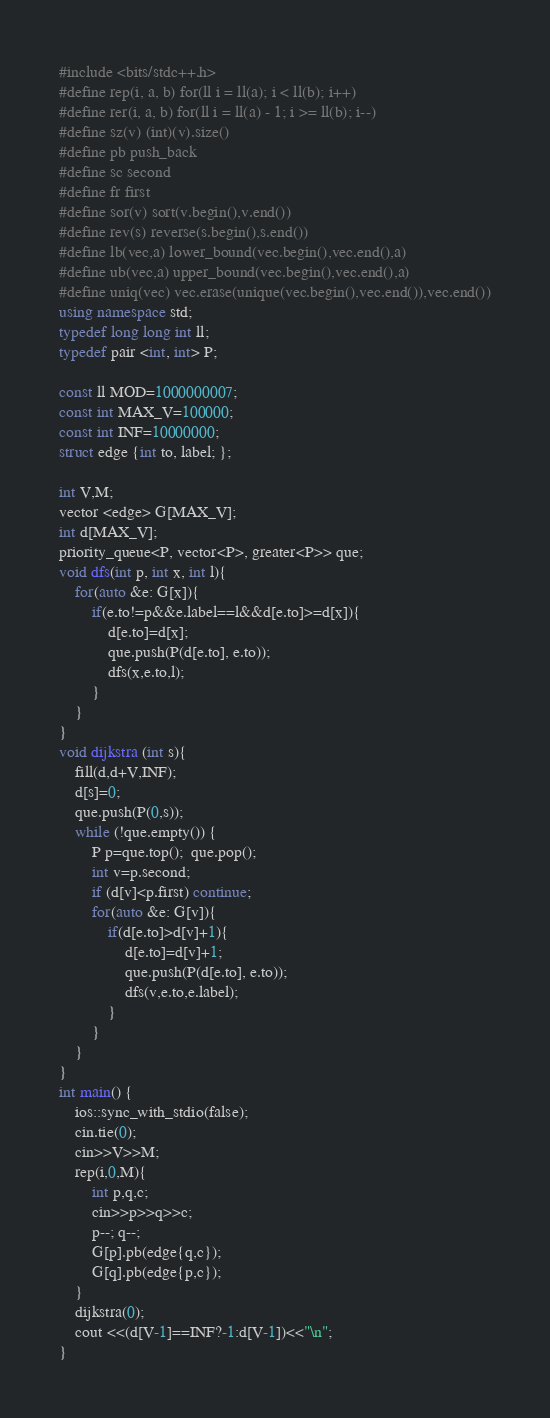<code> <loc_0><loc_0><loc_500><loc_500><_C++_>#include <bits/stdc++.h>
#define rep(i, a, b) for(ll i = ll(a); i < ll(b); i++)
#define rer(i, a, b) for(ll i = ll(a) - 1; i >= ll(b); i--)
#define sz(v) (int)(v).size()
#define pb push_back
#define sc second
#define fr first
#define sor(v) sort(v.begin(),v.end())
#define rev(s) reverse(s.begin(),s.end())
#define lb(vec,a) lower_bound(vec.begin(),vec.end(),a)
#define ub(vec,a) upper_bound(vec.begin(),vec.end(),a)
#define uniq(vec) vec.erase(unique(vec.begin(),vec.end()),vec.end())
using namespace std;
typedef long long int ll;
typedef pair <int, int> P;

const ll MOD=1000000007;
const int MAX_V=100000;
const int INF=10000000;
struct edge {int to, label; };

int V,M;
vector <edge> G[MAX_V];
int d[MAX_V];
priority_queue<P, vector<P>, greater<P>> que;
void dfs(int p, int x, int l){
    for(auto &e: G[x]){
        if(e.to!=p&&e.label==l&&d[e.to]>=d[x]){
            d[e.to]=d[x];
            que.push(P(d[e.to], e.to));
            dfs(x,e.to,l);
        }
    }
}
void dijkstra (int s){
    fill(d,d+V,INF);
    d[s]=0;
    que.push(P(0,s));
    while (!que.empty()) {
        P p=que.top();  que.pop();
        int v=p.second;
        if (d[v]<p.first) continue;
        for(auto &e: G[v]){
            if(d[e.to]>d[v]+1){
                d[e.to]=d[v]+1;
                que.push(P(d[e.to], e.to));
                dfs(v,e.to,e.label);
            }
        }
    }
}
int main() {
    ios::sync_with_stdio(false);
    cin.tie(0);
    cin>>V>>M;
    rep(i,0,M){
        int p,q,c;
        cin>>p>>q>>c;
        p--; q--;
        G[p].pb(edge{q,c});
        G[q].pb(edge{p,c});
    }
    dijkstra(0);
    cout <<(d[V-1]==INF?-1:d[V-1])<<"\n";
}</code> 